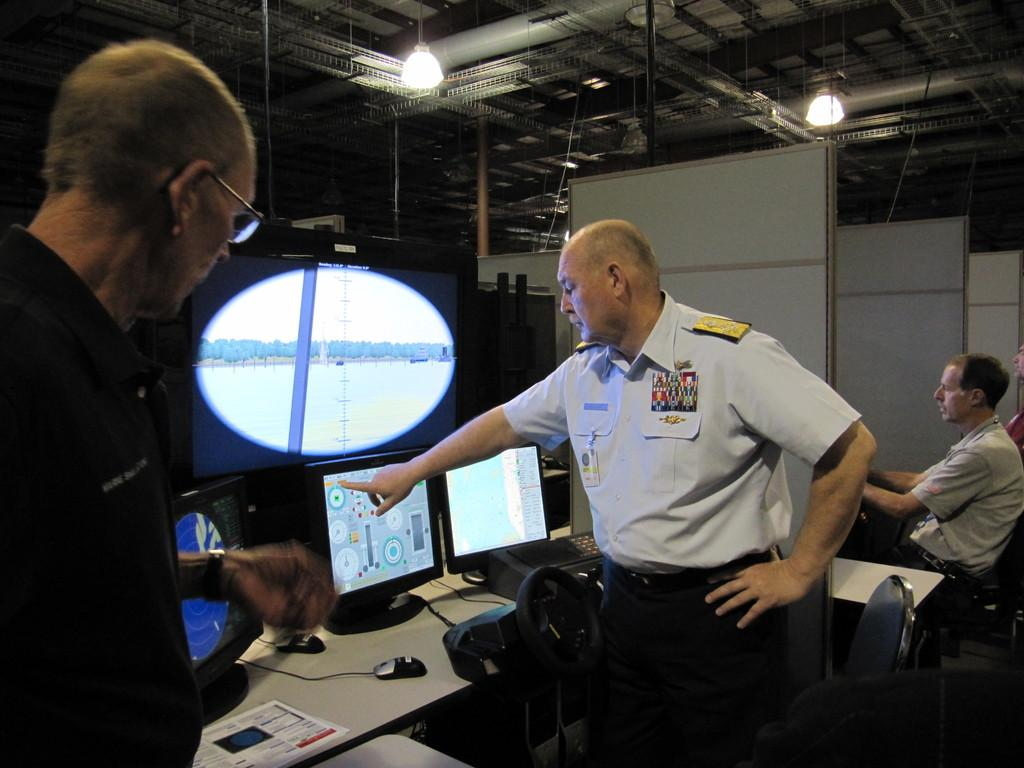How many people are in the image? There is a group of people in the image. Can you describe the clothing of one person in the group? One person in front is wearing a white and black color dress. What can be seen in the background of the image? There are lights and screens visible in the background of the image. How do the geese react to the rainstorm in the image? There are no geese or rainstorm present in the image. What type of rice is being served on the plates in the image? There are no plates or rice visible in the image. 